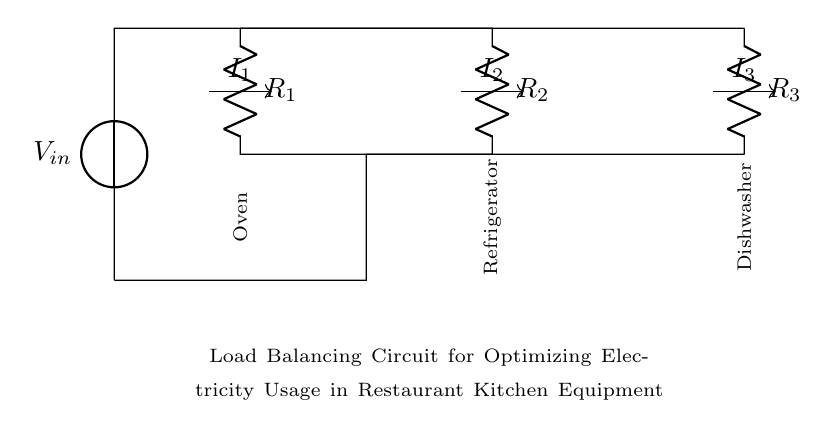What components are present in the circuit? The components shown in the circuit diagram include three resistors labeled R1, R2, and R3, and a voltage source labeled V_in.
Answer: Three resistors, one voltage source What is the function of the voltage source in this circuit? The voltage source provides the electrical potential that drives current through the resistors, enabling load balancing among the kitchen equipment.
Answer: To drive current Which kitchen equipment corresponds to R2 in the circuit? R2 is connected to the Refrigerator, as indicated by the label next to it in the circuit diagram.
Answer: Refrigerator How many paths for current flow are present in this load balancing circuit? The circuit diagram shows three parallel paths for current flow, corresponding to the three resistors.
Answer: Three If R1 is 10 ohms, R2 is 15 ohms, and R3 is 20 ohms, which resistor carries the most current? Using the current divider principle, the current gives more proportion to the lower resistance. R1 carries the most current because it has the lowest resistance value.
Answer: R1 What happens to the total current if one of the resistors is removed? Removing a resistor would increase the total current flowing through the circuit, as the total resistance decreases, leading to a higher total current according to Ohm's law.
Answer: Total current increases What is the primary advantage of using a current divider in this circuit? The current divider optimizes electricity usage by distributing the available current to different loads (kitchen equipment) based on their resistance values, enhancing efficiency.
Answer: Optimizes electricity usage 